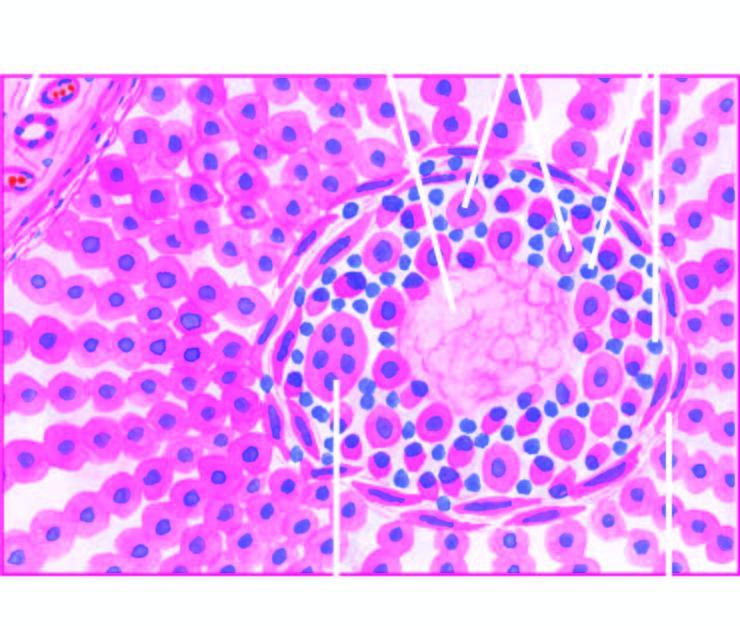what is surrounded by palisades of macrophages and plasma cells marginated peripherally by fibroblasts?
Answer the question using a single word or phrase. Central coagulative necrosis 